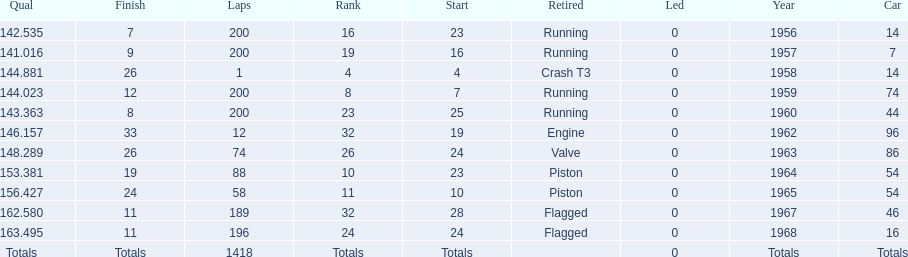Tell me the number of times he finished above 10th place. 3. 